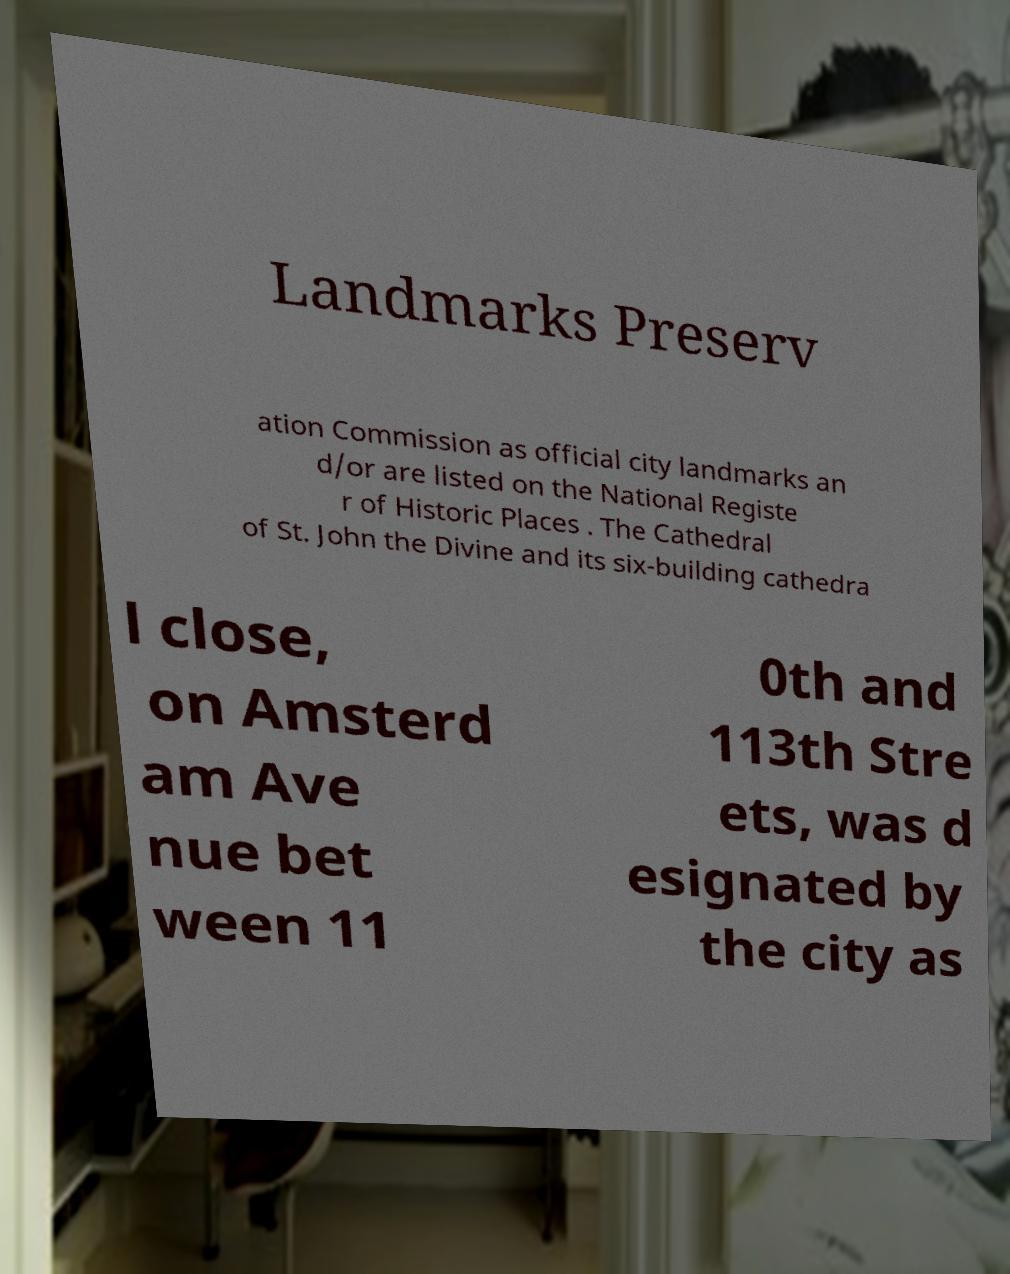Can you accurately transcribe the text from the provided image for me? Landmarks Preserv ation Commission as official city landmarks an d/or are listed on the National Registe r of Historic Places . The Cathedral of St. John the Divine and its six-building cathedra l close, on Amsterd am Ave nue bet ween 11 0th and 113th Stre ets, was d esignated by the city as 